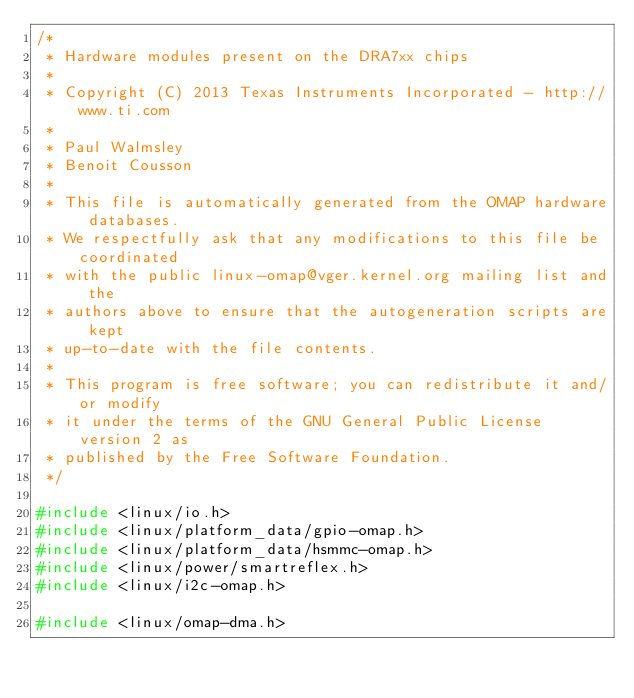Convert code to text. <code><loc_0><loc_0><loc_500><loc_500><_C_>/*
 * Hardware modules present on the DRA7xx chips
 *
 * Copyright (C) 2013 Texas Instruments Incorporated - http://www.ti.com
 *
 * Paul Walmsley
 * Benoit Cousson
 *
 * This file is automatically generated from the OMAP hardware databases.
 * We respectfully ask that any modifications to this file be coordinated
 * with the public linux-omap@vger.kernel.org mailing list and the
 * authors above to ensure that the autogeneration scripts are kept
 * up-to-date with the file contents.
 *
 * This program is free software; you can redistribute it and/or modify
 * it under the terms of the GNU General Public License version 2 as
 * published by the Free Software Foundation.
 */

#include <linux/io.h>
#include <linux/platform_data/gpio-omap.h>
#include <linux/platform_data/hsmmc-omap.h>
#include <linux/power/smartreflex.h>
#include <linux/i2c-omap.h>

#include <linux/omap-dma.h></code> 